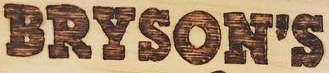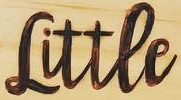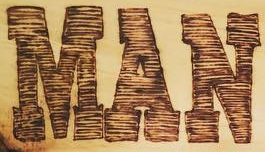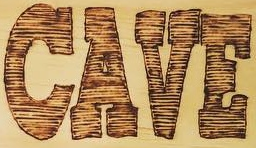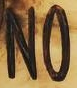Transcribe the words shown in these images in order, separated by a semicolon. BRYSON'S; Littee; MAN; CAVE; NO 